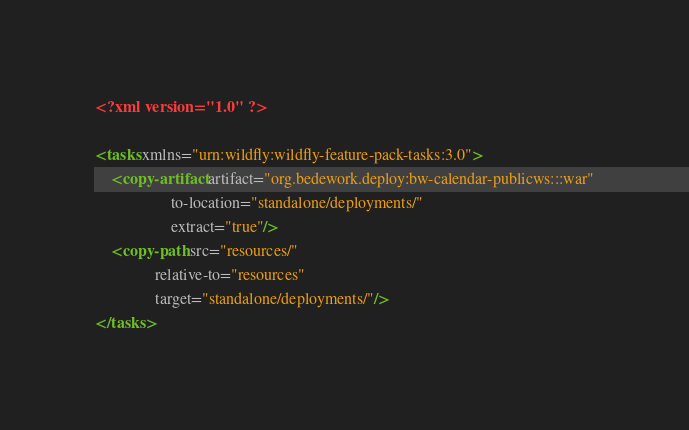Convert code to text. <code><loc_0><loc_0><loc_500><loc_500><_XML_><?xml version="1.0" ?>

<tasks xmlns="urn:wildfly:wildfly-feature-pack-tasks:3.0">
    <copy-artifact artifact="org.bedework.deploy:bw-calendar-publicws:::war"
                   to-location="standalone/deployments/"
                   extract="true"/>
    <copy-path src="resources/"
               relative-to="resources"
               target="standalone/deployments/"/>
</tasks>
</code> 